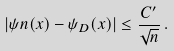Convert formula to latex. <formula><loc_0><loc_0><loc_500><loc_500>\left | \psi n ( x ) - \psi _ { D } ( x ) \right | \leq \frac { C ^ { \prime } } { \sqrt { n } } \, .</formula> 